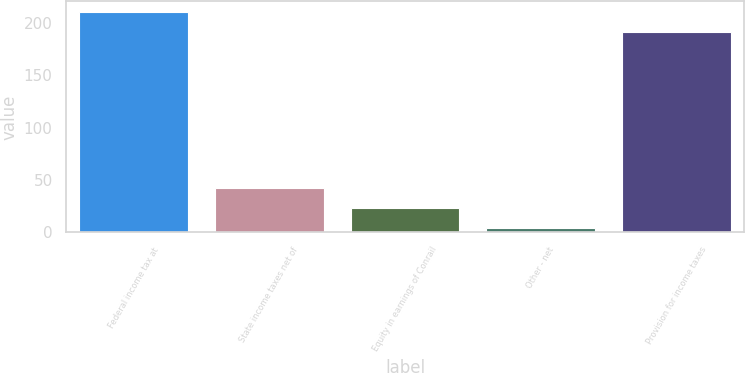Convert chart to OTSL. <chart><loc_0><loc_0><loc_500><loc_500><bar_chart><fcel>Federal income tax at<fcel>State income taxes net of<fcel>Equity in earnings of Conrail<fcel>Other - net<fcel>Provision for income taxes<nl><fcel>210<fcel>42<fcel>23<fcel>4<fcel>191<nl></chart> 